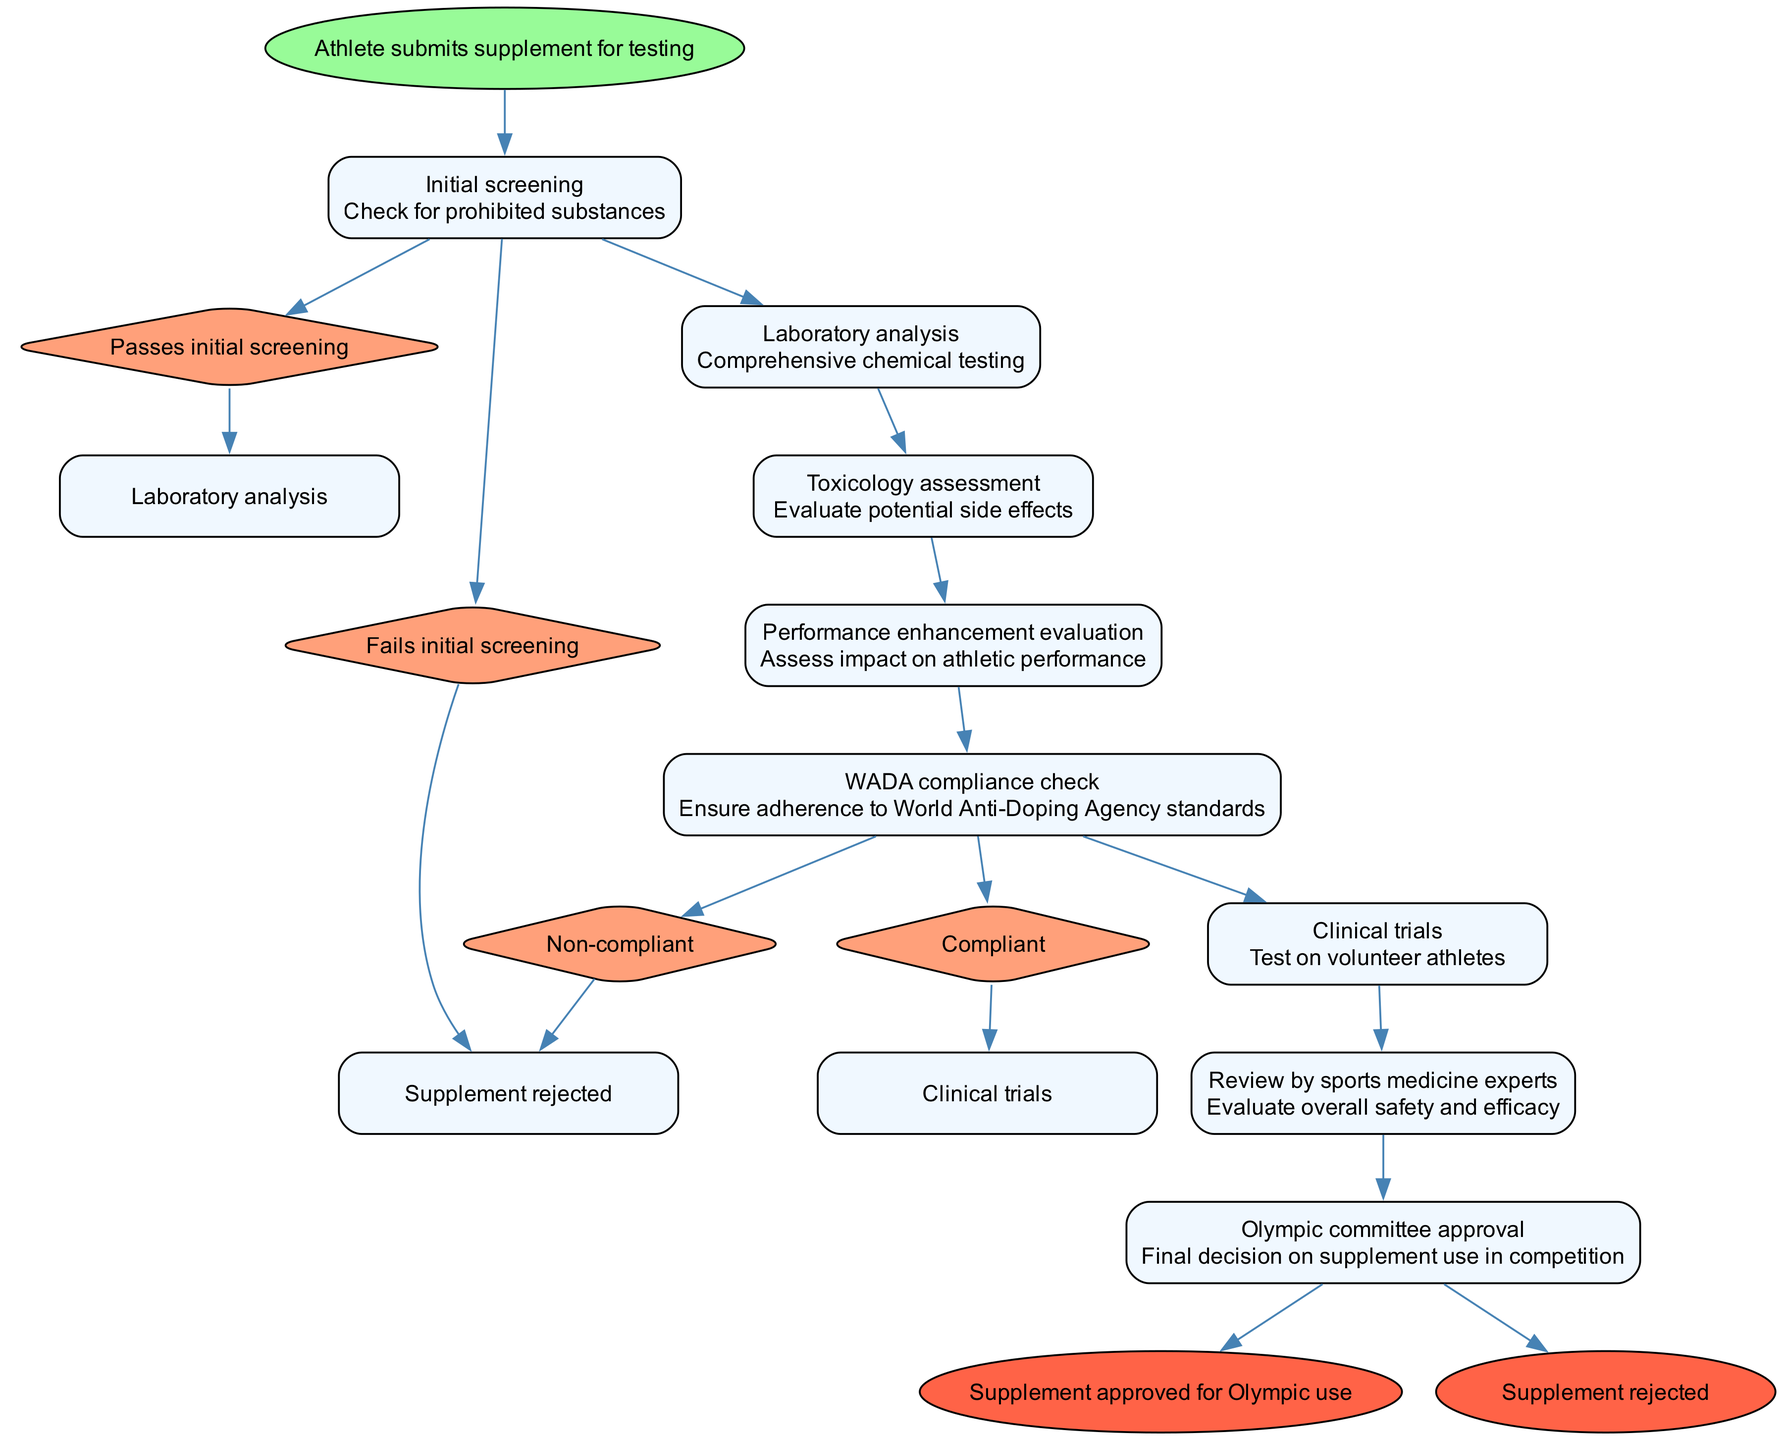What is the starting point of the pathway? The starting point of the pathway, as indicated in the diagram, is clearly labeled as "Athlete submits supplement for testing." This directly stems from the initial node that initiates the sequence of steps.
Answer: Athlete submits supplement for testing How many steps are there before clinical trials? To answer this, we count the steps listed in the diagram prior to reaching "Clinical trials." The sequence includes Initial screening, Laboratory analysis, Toxicology assessment, Performance enhancement evaluation, and WADA compliance check, totaling five steps.
Answer: 5 What happens if the supplement fails the initial screening? According to the options provided in the "Initial screening" step of the diagram, if the supplement fails, it goes directly to the endpoint "Supplement rejected." This indicates that there is no further action taken regarding the supplement in this scenario.
Answer: Supplement rejected What is the purpose of the WADA compliance check? The WADA compliance check, as described in the diagram, is designed to ensure adherence to World Anti-Doping Agency standards. This is a critical step in determining whether the supplement can proceed further in the approval process.
Answer: Ensure adherence to World Anti-Doping Agency standards Which step follows the performance enhancement evaluation? Following the performance enhancement evaluation, the next step in the pathway is the WADA compliance check. This is sequentially listed in the diagram after assessing the impact of the supplement on athletic performance.
Answer: WADA compliance check How many options are presented after the WADA compliance check? The WADA compliance check has two options outlined in the diagram: "Compliant" and "Non-compliant." Each option leads to different next steps, indicating a decision point after this assessment.
Answer: 2 What is the final decision on supplement use in competition called? The final decision on supplement use in competition is labeled as "Olympic committee approval" in the diagram. This indicates that all prior assessments culminate in this critical approval step.
Answer: Olympic committee approval What assessment follows clinical trials? The step that follows clinical trials, as depicted in the diagram, is the "Review by sports medicine experts." This indicates a review process after testing on volunteer athletes.
Answer: Review by sports medicine experts What will happen if the supplement is deemed non-compliant? If the supplement is deemed non-compliant during the WADA compliance check, it will go to the "Supplement rejected" endpoint. This highlights the importance of compliance for the supplement's approval process.
Answer: Supplement rejected 